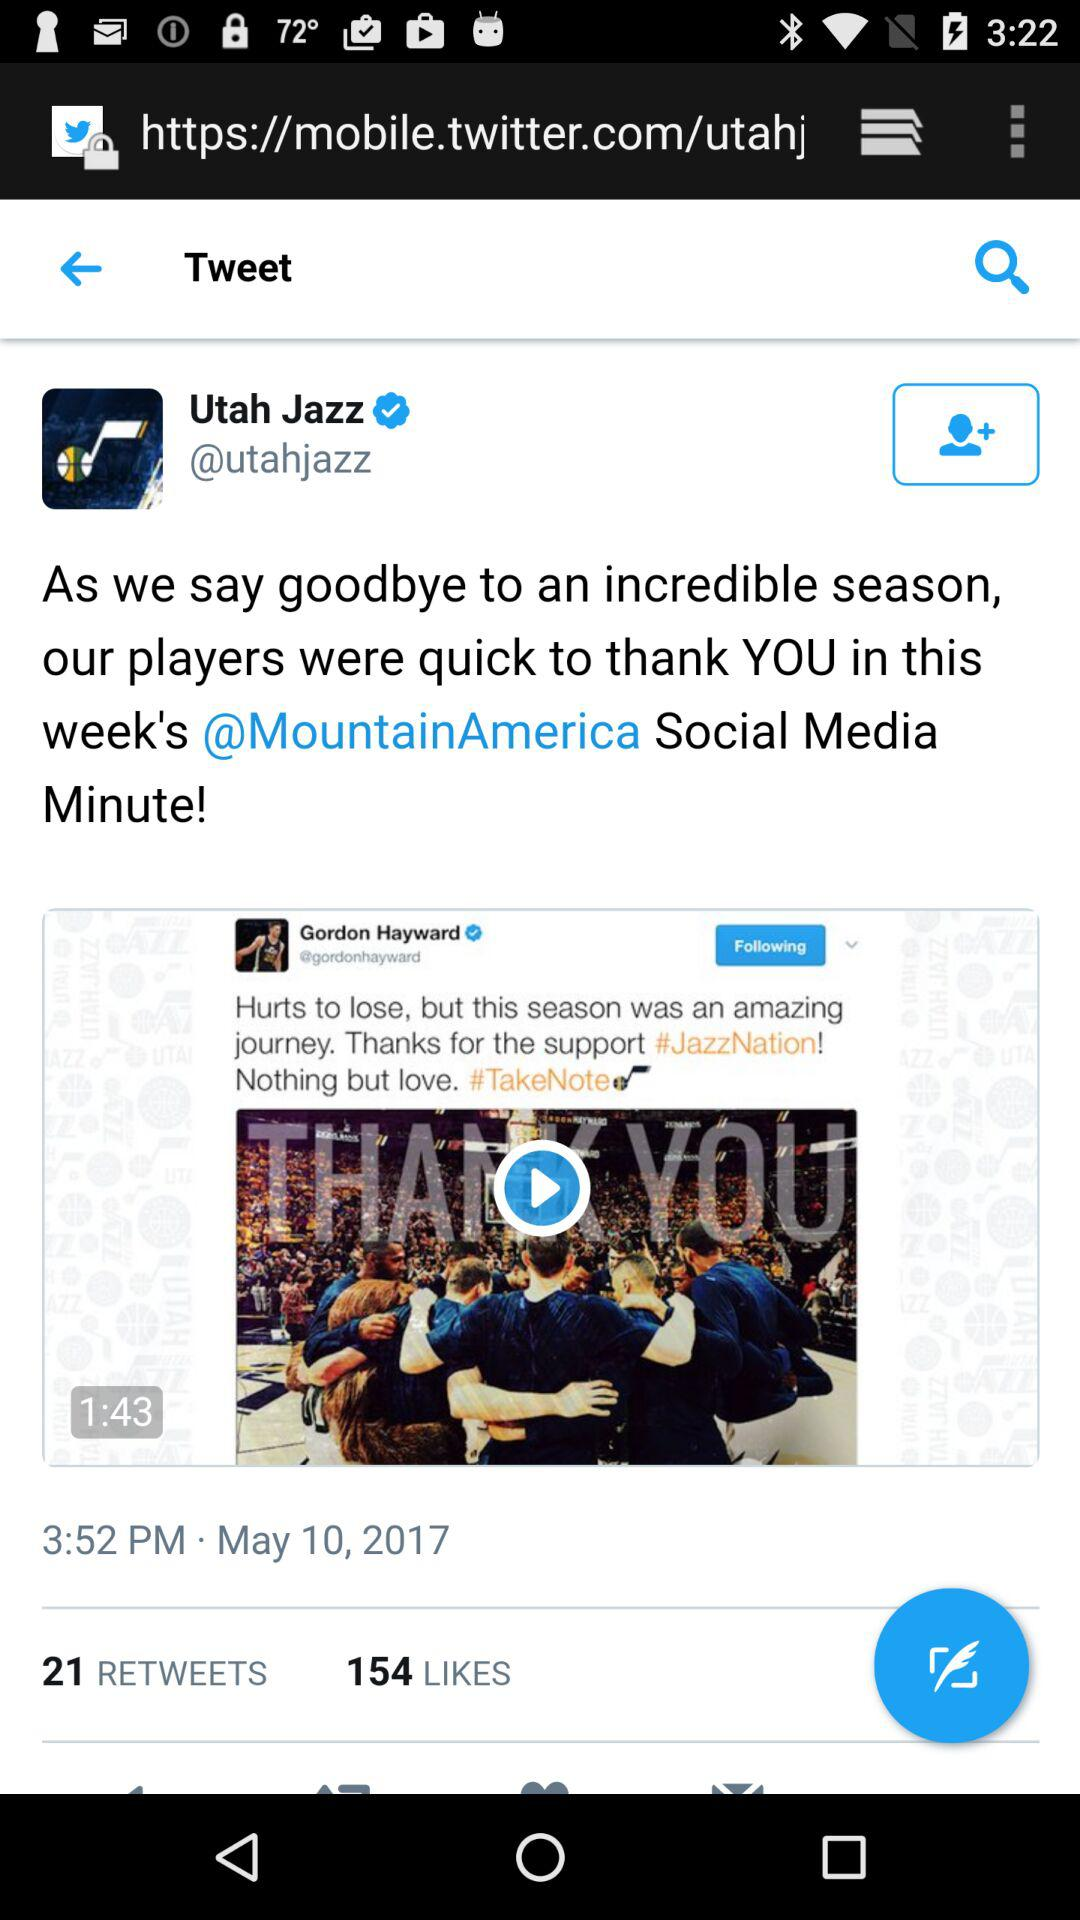How many retweets are there? There are 21 retweets. 